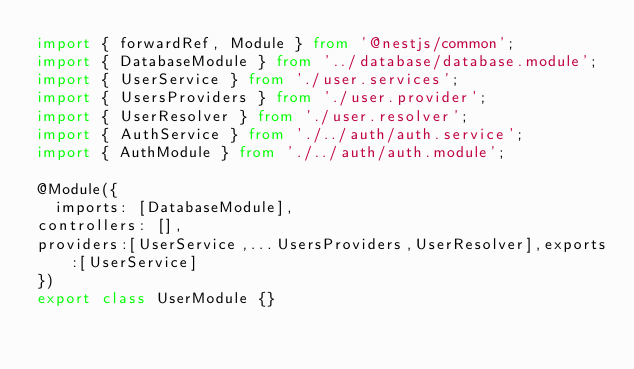<code> <loc_0><loc_0><loc_500><loc_500><_TypeScript_>import { forwardRef, Module } from '@nestjs/common';
import { DatabaseModule } from '../database/database.module';
import { UserService } from './user.services';
import { UsersProviders } from './user.provider';
import { UserResolver } from './user.resolver';
import { AuthService } from './../auth/auth.service';
import { AuthModule } from './../auth/auth.module';

@Module({
  imports: [DatabaseModule],
controllers: [],
providers:[UserService,...UsersProviders,UserResolver],exports:[UserService]
})
export class UserModule {}</code> 